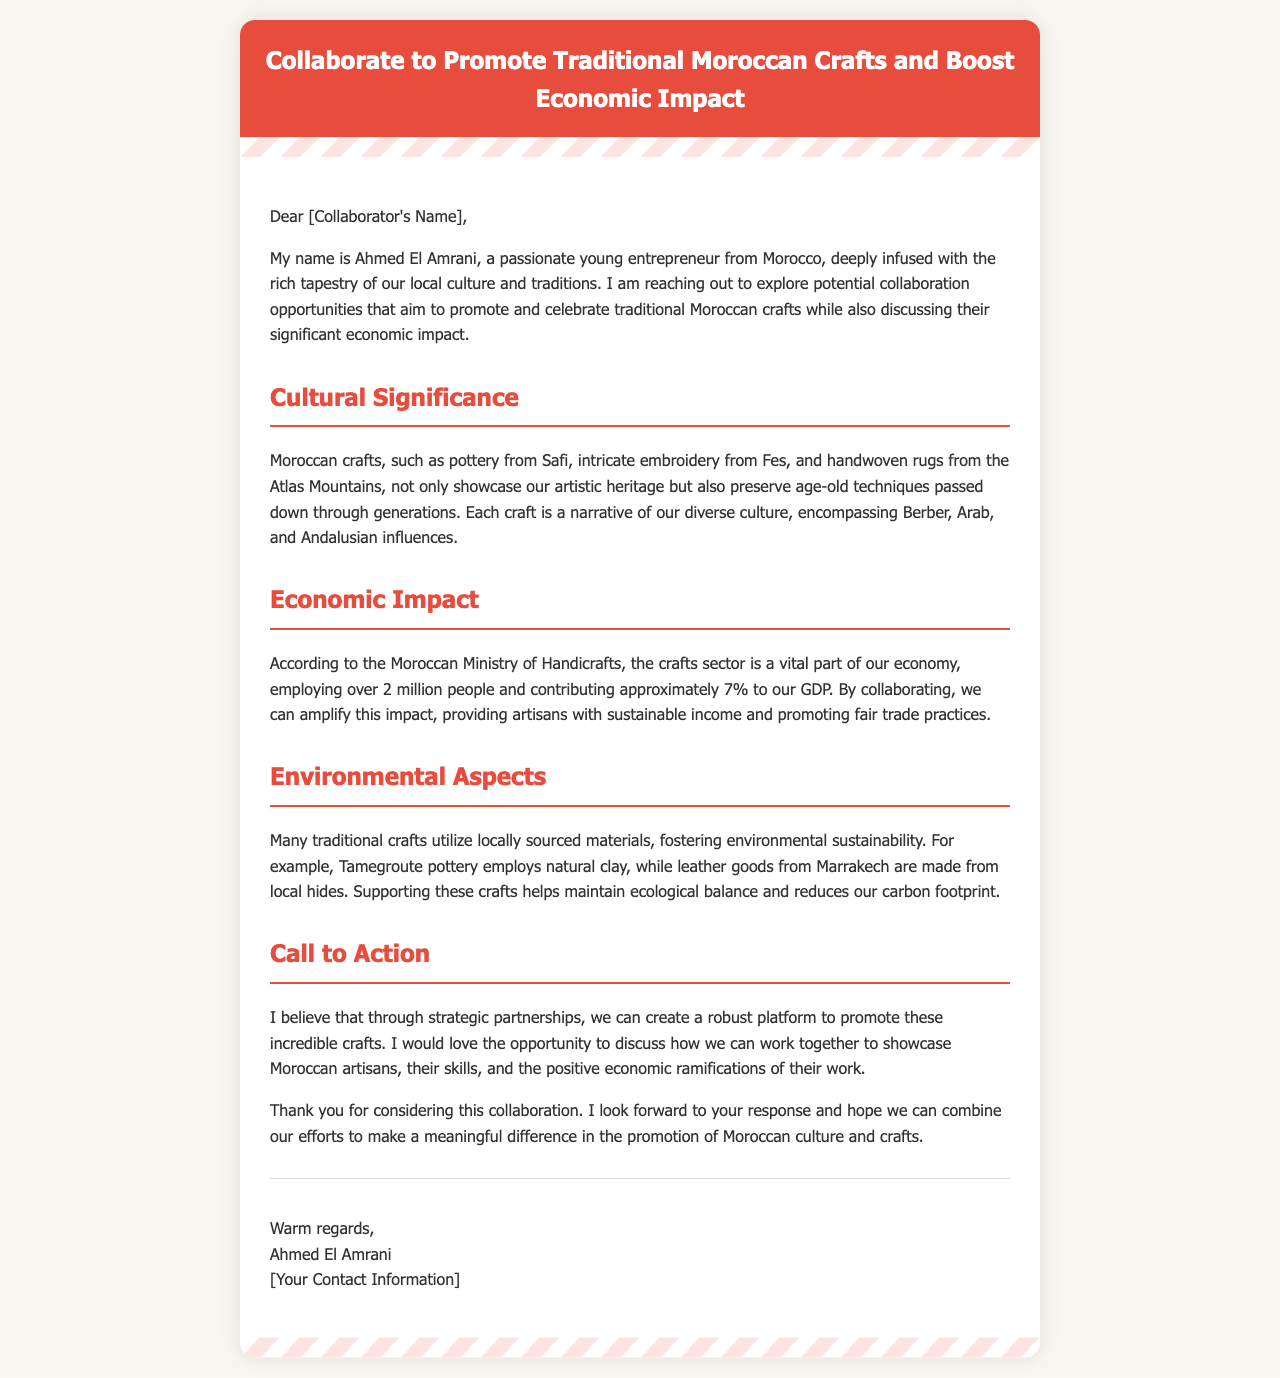What is the sender's name? The sender's name is mentioned at the end of the email, which is Ahmed El Amrani.
Answer: Ahmed El Amrani What is the main theme of the email? The email revolves around potential collaboration in promoting traditional Moroccan crafts and their economic impact.
Answer: Traditional Moroccan crafts How many people does the crafts sector employ? The document states that over 2 million people are employed in the crafts sector.
Answer: 2 million What percentage does the crafts sector contribute to Morocco's GDP? The crafts sector contributes approximately 7% to Morocco's GDP as stated in the document.
Answer: 7% Which city is known for intricate embroidery? The document highlights Fes as the city known for intricate embroidery.
Answer: Fes What materials are used in Tamegroute pottery? The document mentions that Tamegroute pottery employs natural clay as a material.
Answer: Natural clay What is the call to action in the email? The call to action invites collaboration to promote Moroccan artisans and their crafts.
Answer: Promote Moroccan artisans How does supporting traditional crafts benefit the environment? The document explains that these crafts utilize locally sourced materials, which fosters environmental sustainability.
Answer: Environmental sustainability What cultural influences are mentioned regarding Moroccan crafts? The email notes that Moroccan crafts encompass Berber, Arab, and Andalusian influences.
Answer: Berber, Arab, and Andalusian influences 